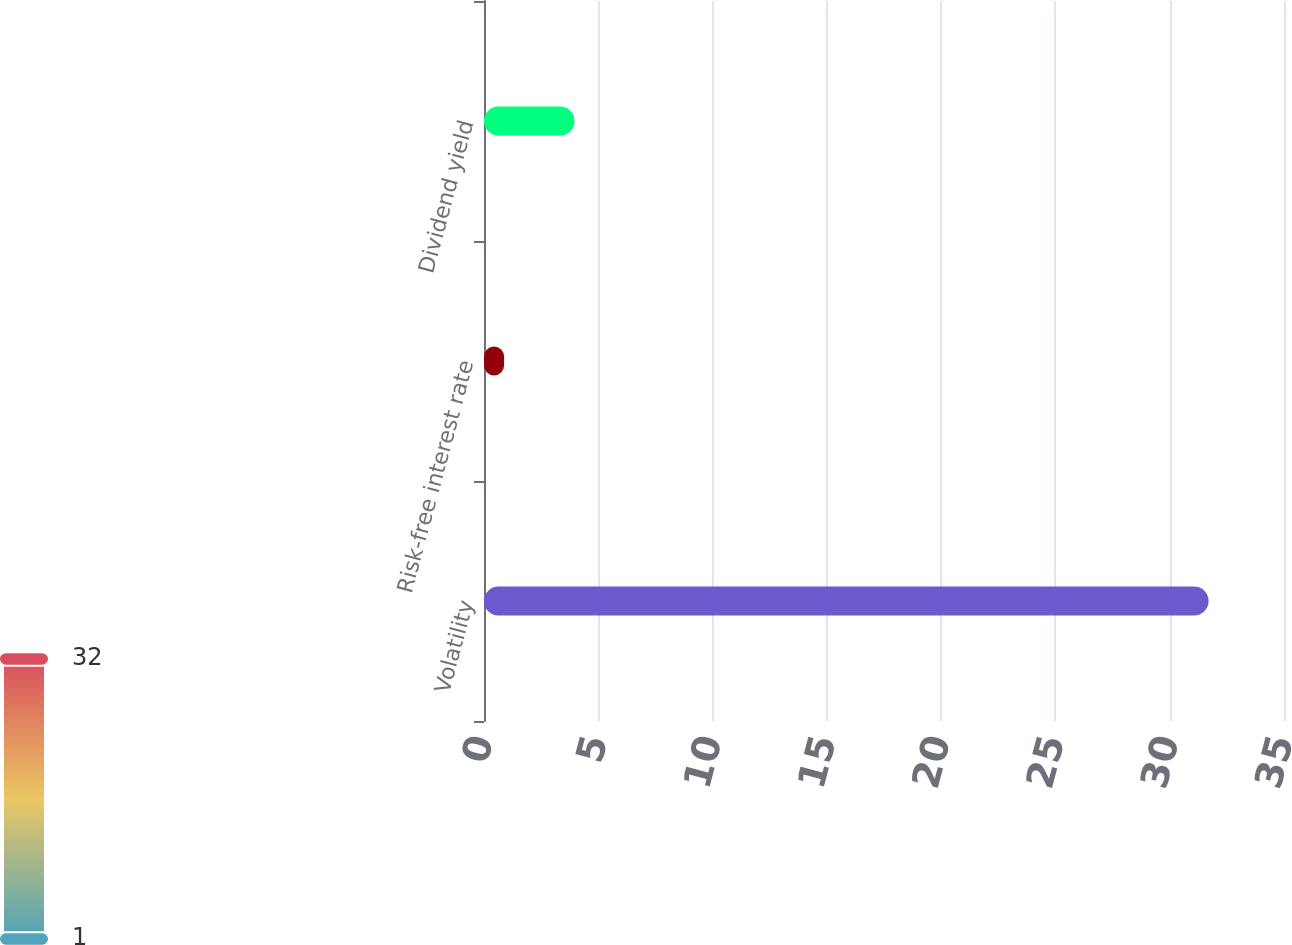<chart> <loc_0><loc_0><loc_500><loc_500><bar_chart><fcel>Volatility<fcel>Risk-free interest rate<fcel>Dividend yield<nl><fcel>31.7<fcel>0.88<fcel>3.96<nl></chart> 